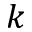Convert formula to latex. <formula><loc_0><loc_0><loc_500><loc_500>k</formula> 